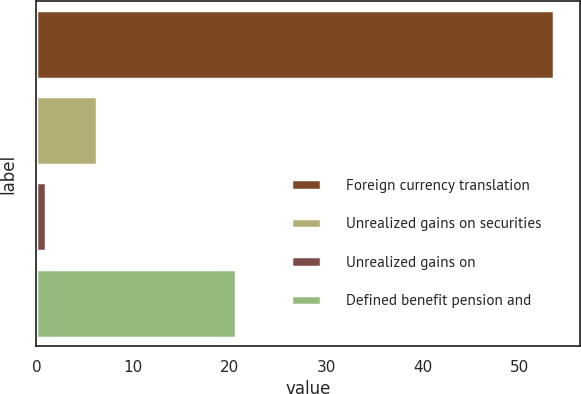Convert chart to OTSL. <chart><loc_0><loc_0><loc_500><loc_500><bar_chart><fcel>Foreign currency translation<fcel>Unrealized gains on securities<fcel>Unrealized gains on<fcel>Defined benefit pension and<nl><fcel>53.5<fcel>6.25<fcel>1<fcel>20.6<nl></chart> 